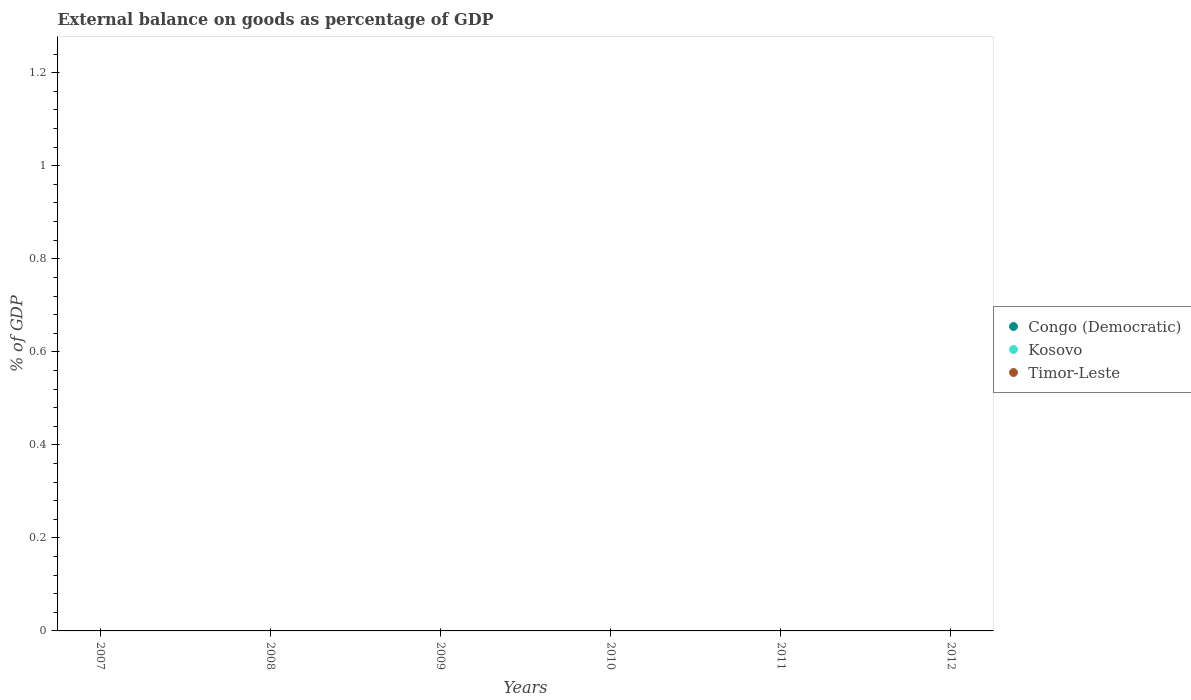Is the number of dotlines equal to the number of legend labels?
Provide a succinct answer. No. What is the average external balance on goods as percentage of GDP in Kosovo per year?
Provide a succinct answer. 0. In how many years, is the external balance on goods as percentage of GDP in Kosovo greater than the average external balance on goods as percentage of GDP in Kosovo taken over all years?
Provide a short and direct response. 0. Does the external balance on goods as percentage of GDP in Congo (Democratic) monotonically increase over the years?
Your answer should be compact. No. Is the external balance on goods as percentage of GDP in Timor-Leste strictly greater than the external balance on goods as percentage of GDP in Kosovo over the years?
Your response must be concise. No. Is the external balance on goods as percentage of GDP in Congo (Democratic) strictly less than the external balance on goods as percentage of GDP in Timor-Leste over the years?
Keep it short and to the point. No. How many dotlines are there?
Ensure brevity in your answer.  0. What is the difference between two consecutive major ticks on the Y-axis?
Your answer should be compact. 0.2. Are the values on the major ticks of Y-axis written in scientific E-notation?
Offer a terse response. No. Does the graph contain any zero values?
Provide a short and direct response. Yes. Does the graph contain grids?
Your response must be concise. No. Where does the legend appear in the graph?
Offer a terse response. Center right. How many legend labels are there?
Ensure brevity in your answer.  3. How are the legend labels stacked?
Offer a very short reply. Vertical. What is the title of the graph?
Your response must be concise. External balance on goods as percentage of GDP. What is the label or title of the X-axis?
Your answer should be very brief. Years. What is the label or title of the Y-axis?
Offer a very short reply. % of GDP. What is the % of GDP in Congo (Democratic) in 2007?
Your answer should be very brief. 0. What is the % of GDP of Kosovo in 2007?
Offer a terse response. 0. What is the % of GDP of Timor-Leste in 2007?
Your response must be concise. 0. What is the % of GDP in Congo (Democratic) in 2008?
Offer a terse response. 0. What is the % of GDP of Timor-Leste in 2008?
Provide a succinct answer. 0. What is the % of GDP of Congo (Democratic) in 2009?
Your answer should be very brief. 0. What is the % of GDP in Kosovo in 2009?
Your response must be concise. 0. What is the % of GDP in Timor-Leste in 2009?
Provide a short and direct response. 0. What is the % of GDP in Timor-Leste in 2010?
Provide a short and direct response. 0. What is the % of GDP in Congo (Democratic) in 2011?
Offer a very short reply. 0. What is the % of GDP of Timor-Leste in 2011?
Give a very brief answer. 0. What is the % of GDP of Congo (Democratic) in 2012?
Give a very brief answer. 0. What is the % of GDP in Timor-Leste in 2012?
Give a very brief answer. 0. What is the total % of GDP of Timor-Leste in the graph?
Provide a short and direct response. 0. What is the average % of GDP of Kosovo per year?
Make the answer very short. 0. What is the average % of GDP in Timor-Leste per year?
Your response must be concise. 0. 